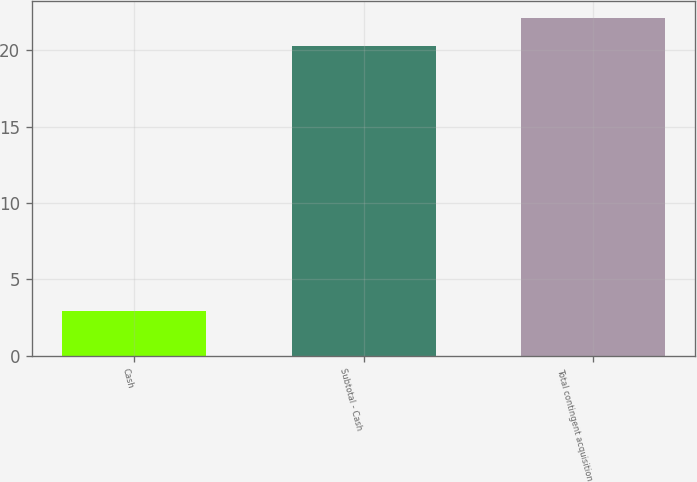Convert chart. <chart><loc_0><loc_0><loc_500><loc_500><bar_chart><fcel>Cash<fcel>Subtotal - Cash<fcel>Total contingent acquisition<nl><fcel>2.9<fcel>20.3<fcel>22.09<nl></chart> 